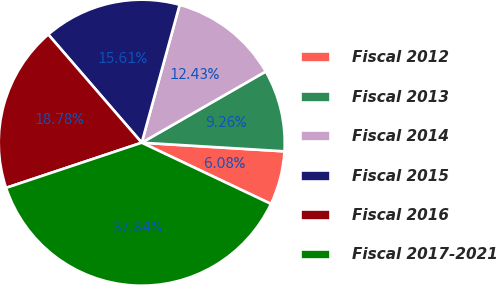Convert chart to OTSL. <chart><loc_0><loc_0><loc_500><loc_500><pie_chart><fcel>Fiscal 2012<fcel>Fiscal 2013<fcel>Fiscal 2014<fcel>Fiscal 2015<fcel>Fiscal 2016<fcel>Fiscal 2017-2021<nl><fcel>6.08%<fcel>9.26%<fcel>12.43%<fcel>15.61%<fcel>18.78%<fcel>37.84%<nl></chart> 